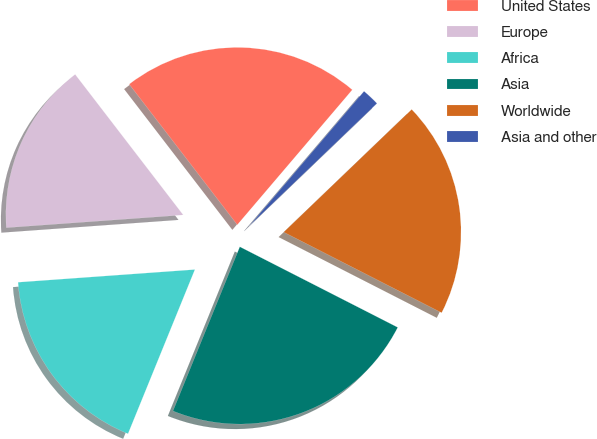Convert chart. <chart><loc_0><loc_0><loc_500><loc_500><pie_chart><fcel>United States<fcel>Europe<fcel>Africa<fcel>Asia<fcel>Worldwide<fcel>Asia and other<nl><fcel>21.66%<fcel>15.71%<fcel>17.7%<fcel>23.64%<fcel>19.68%<fcel>1.6%<nl></chart> 